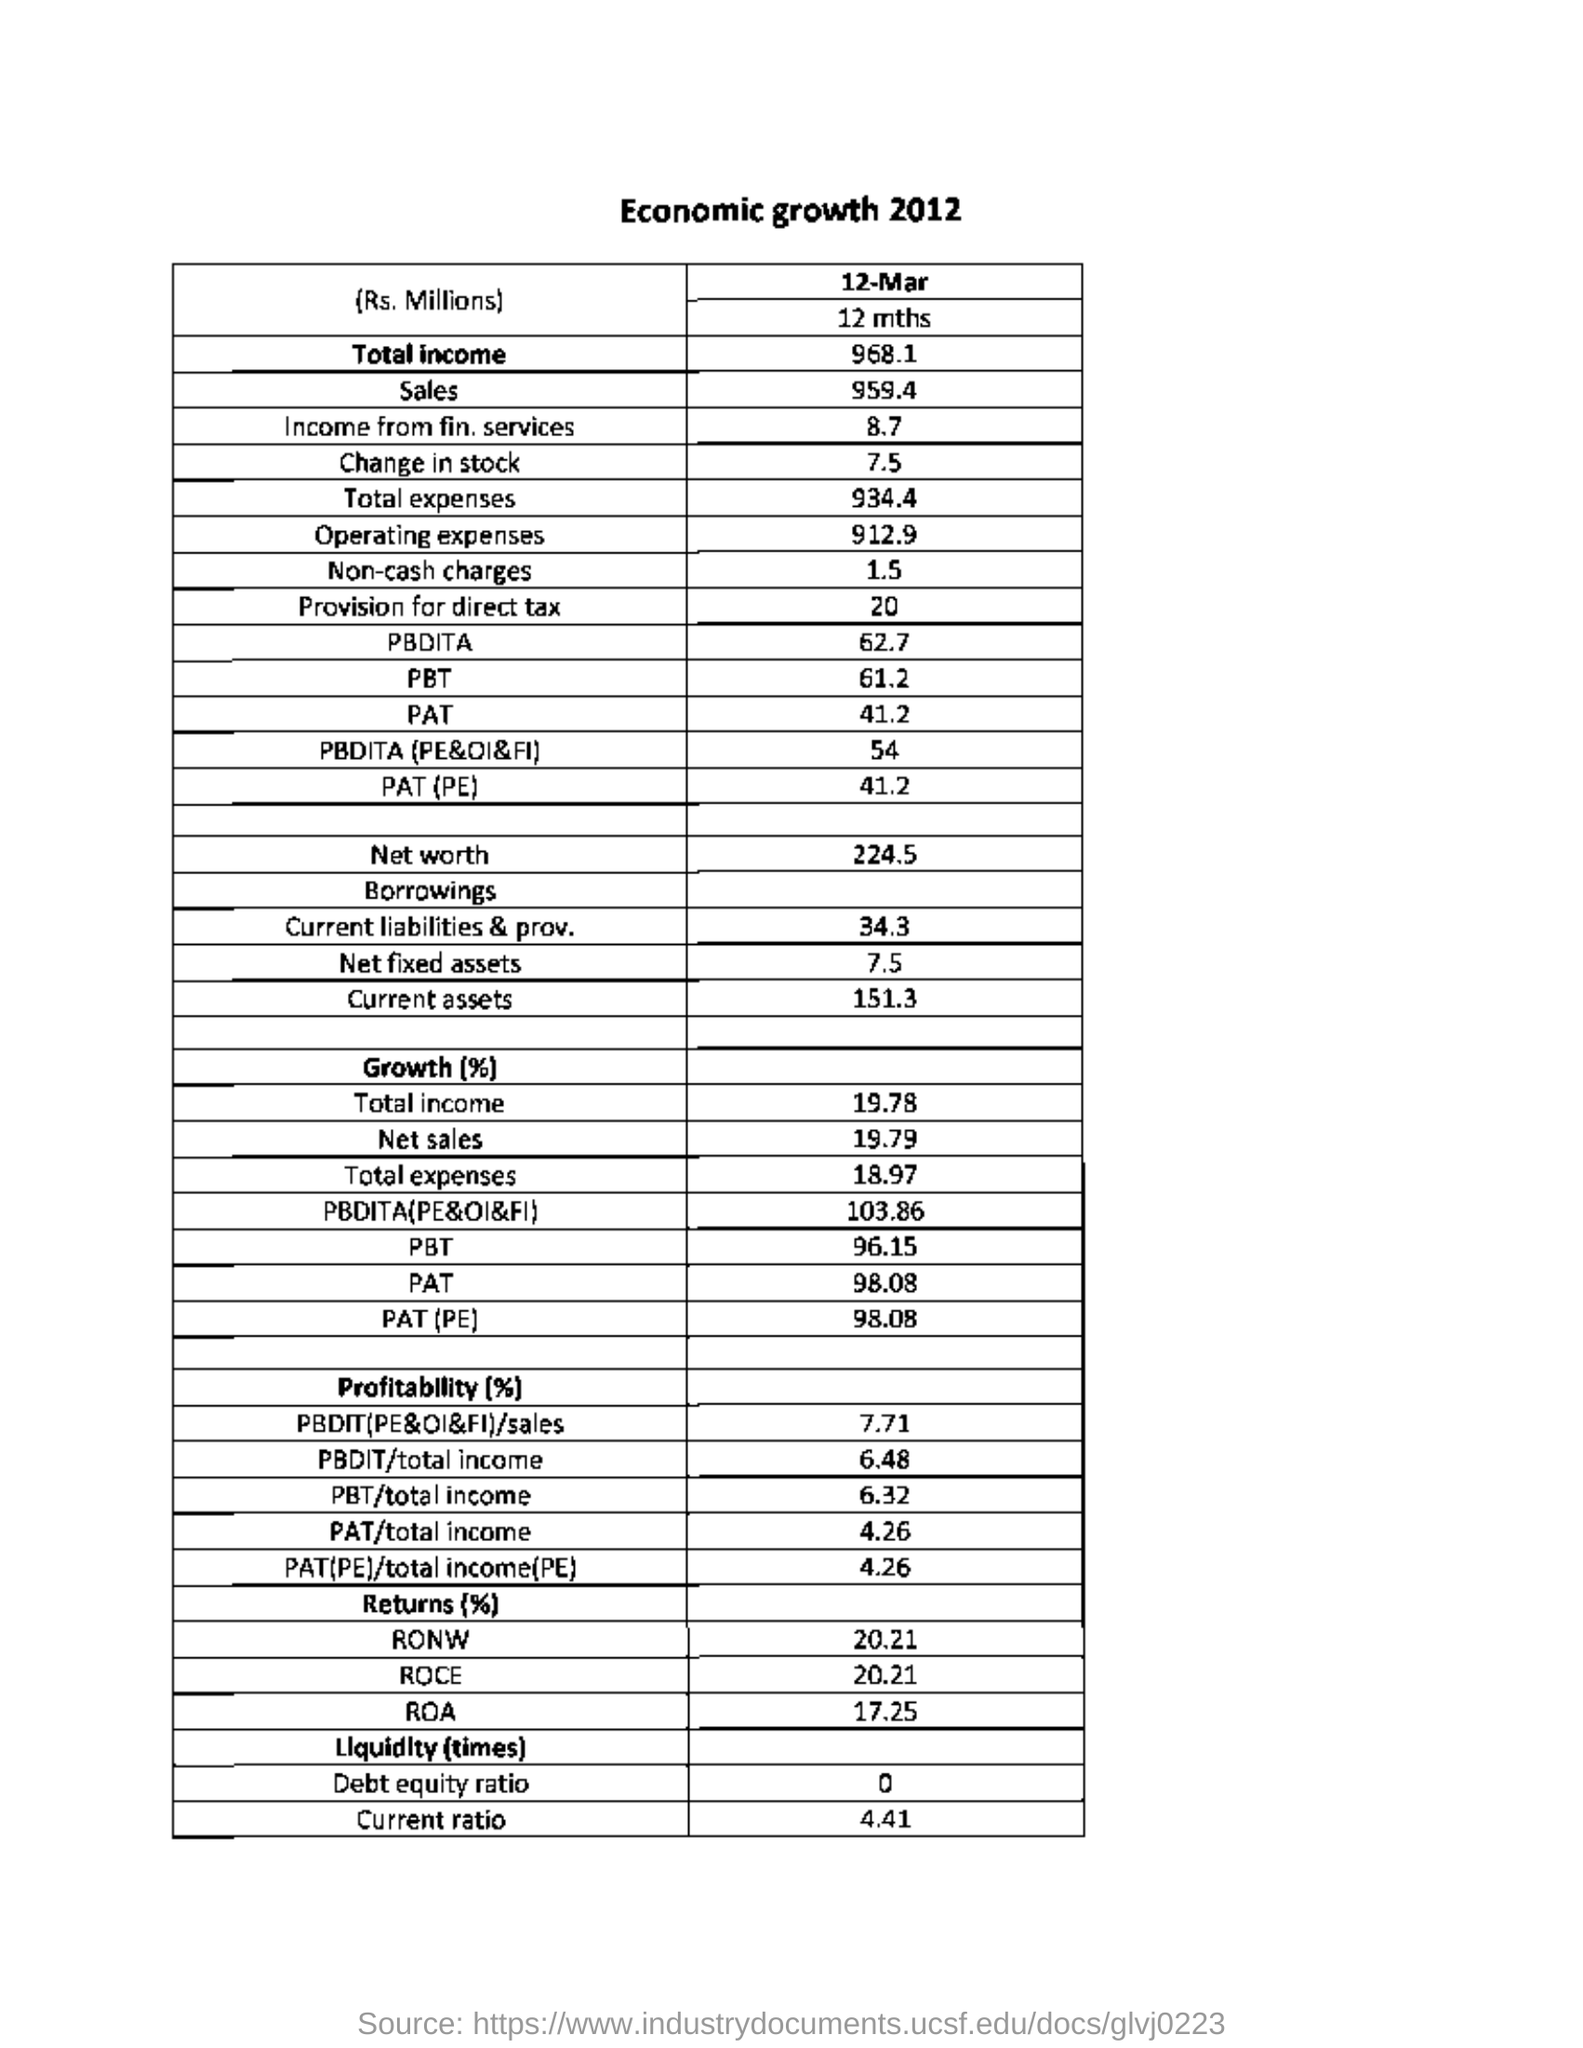Indicate a few pertinent items in this graphic. What is the value of net fixed assets given? It is 7.5.. The net sales for the company mentioned under growth (%) was 19.79%. The current assets value given is 151.3. Total Income" referred under the section of "Growth (%)" is 19.78%. The value of income from financial services is 8.7. 